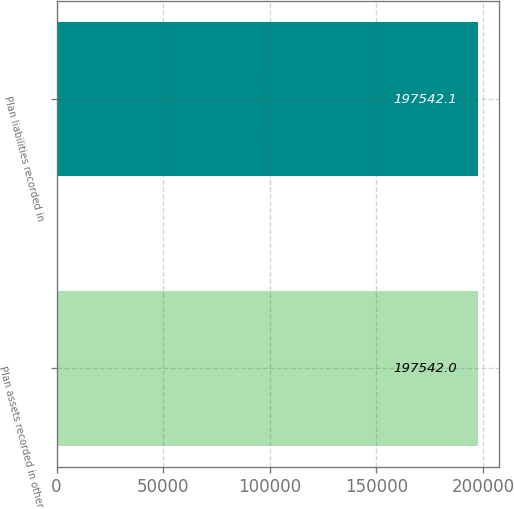Convert chart. <chart><loc_0><loc_0><loc_500><loc_500><bar_chart><fcel>Plan assets recorded in other<fcel>Plan liabilities recorded in<nl><fcel>197542<fcel>197542<nl></chart> 